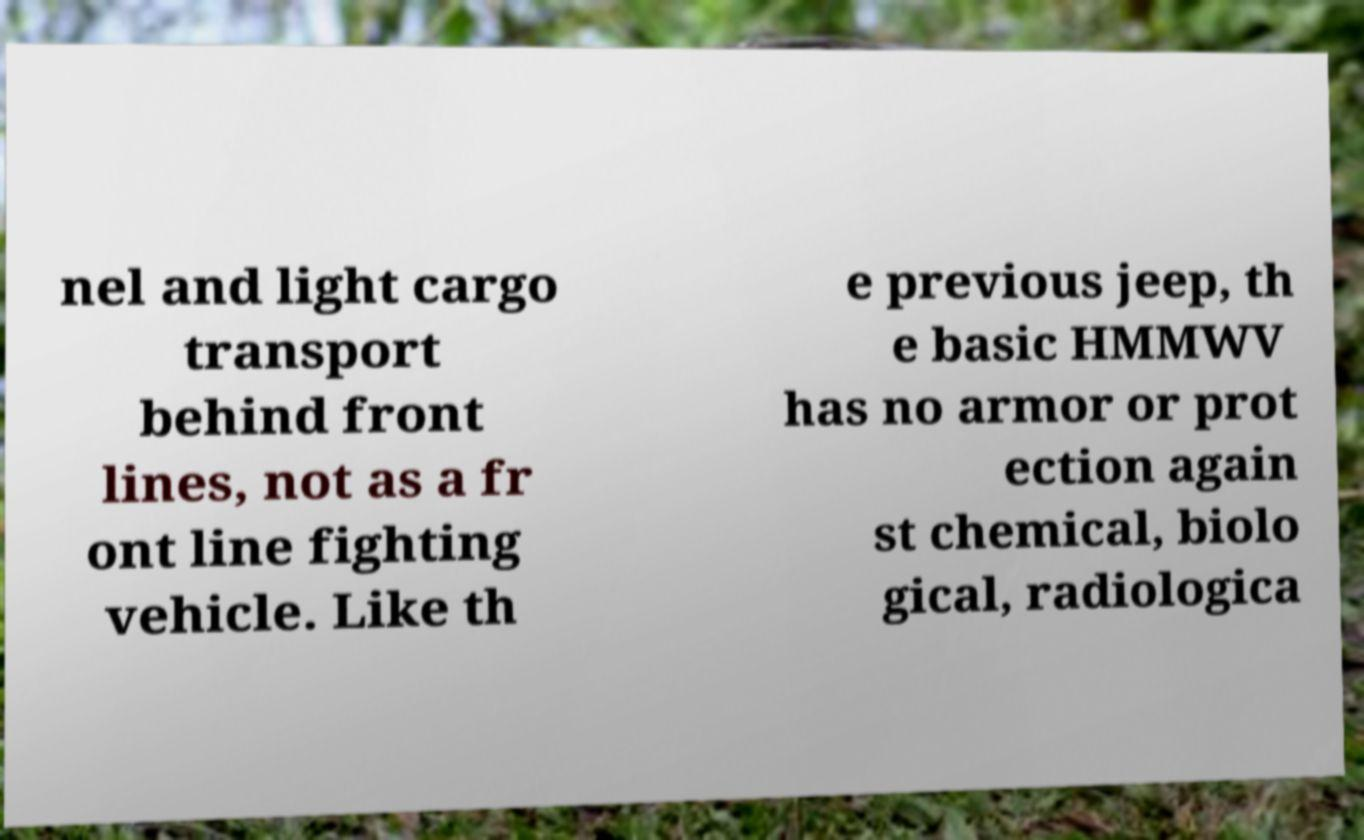Could you assist in decoding the text presented in this image and type it out clearly? nel and light cargo transport behind front lines, not as a fr ont line fighting vehicle. Like th e previous jeep, th e basic HMMWV has no armor or prot ection again st chemical, biolo gical, radiologica 